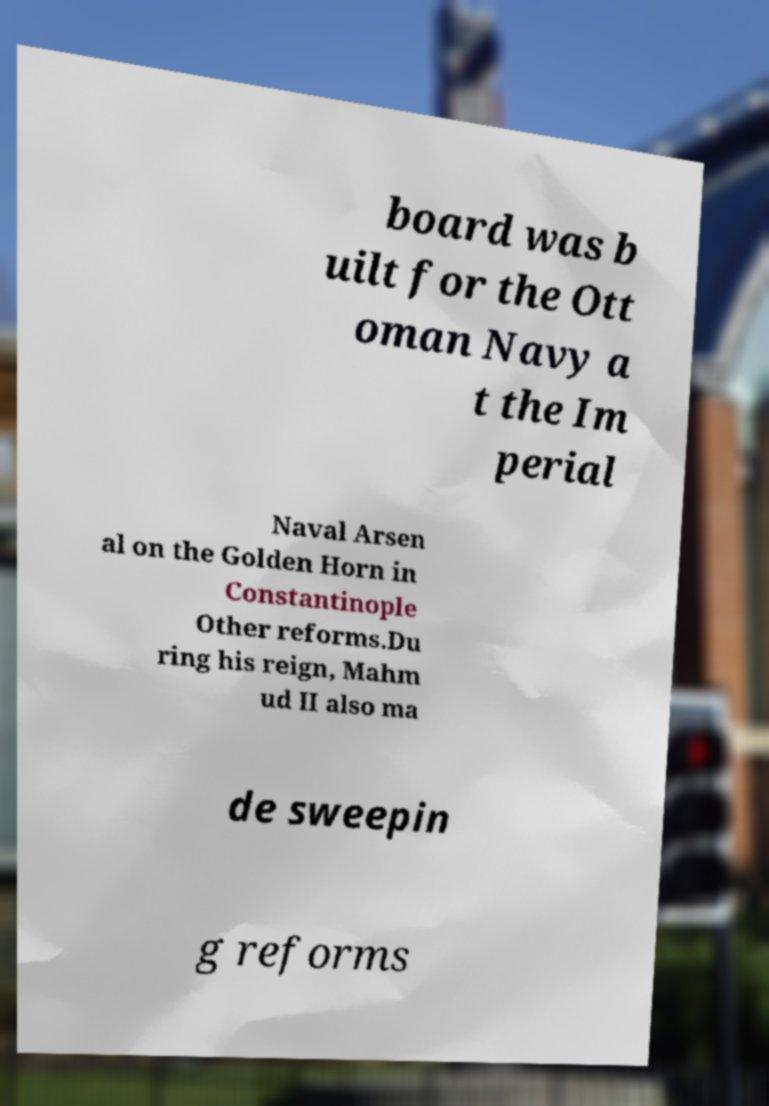Please read and relay the text visible in this image. What does it say? board was b uilt for the Ott oman Navy a t the Im perial Naval Arsen al on the Golden Horn in Constantinople Other reforms.Du ring his reign, Mahm ud II also ma de sweepin g reforms 